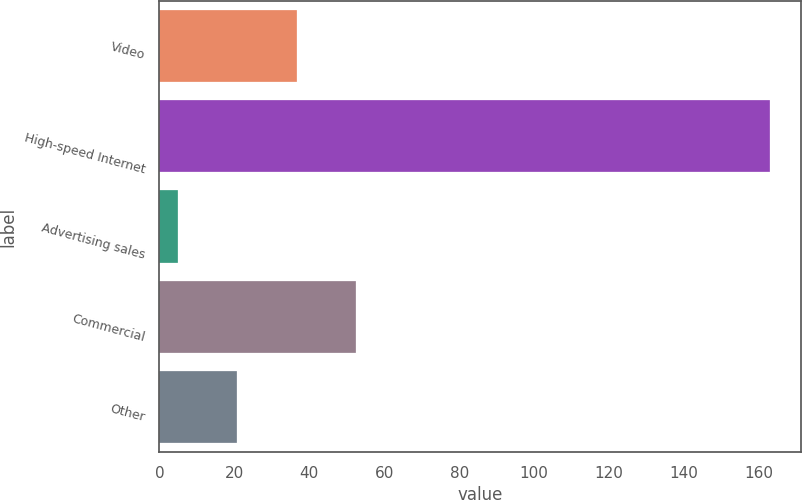Convert chart. <chart><loc_0><loc_0><loc_500><loc_500><bar_chart><fcel>Video<fcel>High-speed Internet<fcel>Advertising sales<fcel>Commercial<fcel>Other<nl><fcel>36.6<fcel>163<fcel>5<fcel>52.4<fcel>20.8<nl></chart> 